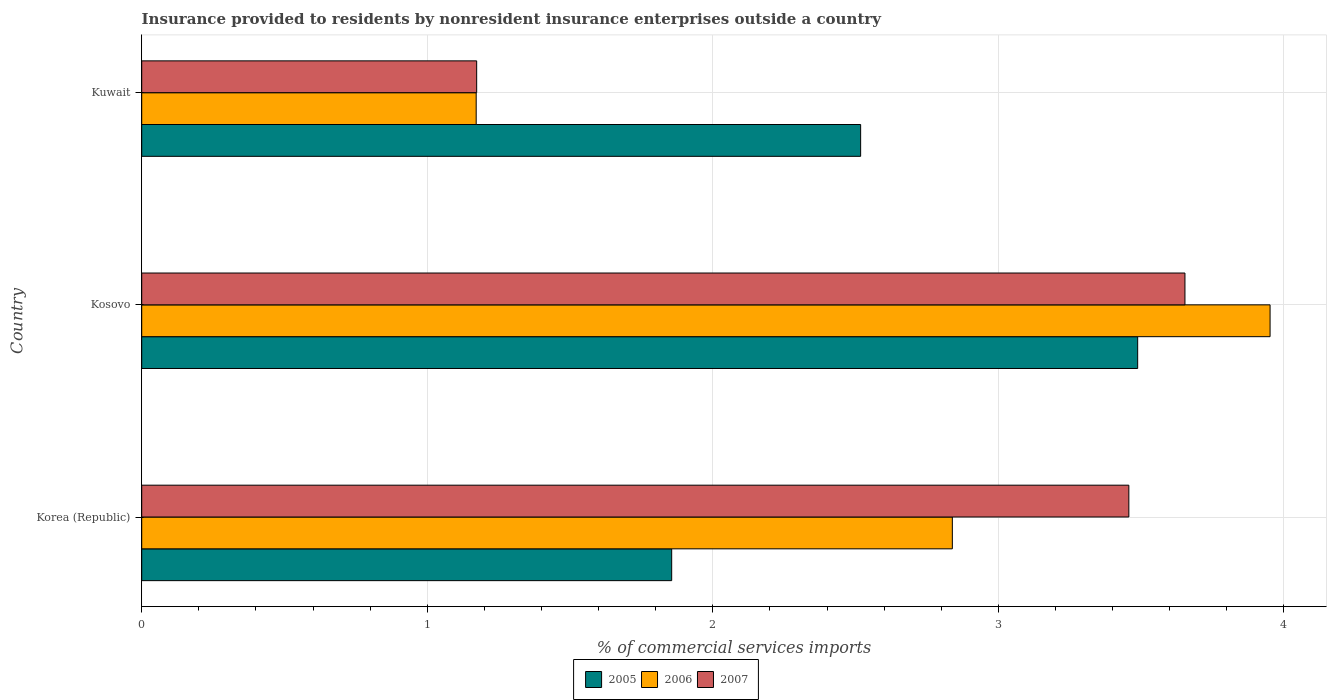How many different coloured bars are there?
Offer a very short reply. 3. How many groups of bars are there?
Your answer should be very brief. 3. Are the number of bars per tick equal to the number of legend labels?
Keep it short and to the point. Yes. Are the number of bars on each tick of the Y-axis equal?
Provide a succinct answer. Yes. How many bars are there on the 1st tick from the top?
Your answer should be compact. 3. How many bars are there on the 2nd tick from the bottom?
Your answer should be very brief. 3. What is the label of the 1st group of bars from the top?
Ensure brevity in your answer.  Kuwait. In how many cases, is the number of bars for a given country not equal to the number of legend labels?
Your response must be concise. 0. What is the Insurance provided to residents in 2006 in Korea (Republic)?
Your response must be concise. 2.84. Across all countries, what is the maximum Insurance provided to residents in 2006?
Your answer should be very brief. 3.95. Across all countries, what is the minimum Insurance provided to residents in 2006?
Your answer should be very brief. 1.17. In which country was the Insurance provided to residents in 2007 maximum?
Provide a succinct answer. Kosovo. In which country was the Insurance provided to residents in 2006 minimum?
Offer a terse response. Kuwait. What is the total Insurance provided to residents in 2007 in the graph?
Offer a terse response. 8.28. What is the difference between the Insurance provided to residents in 2006 in Kosovo and that in Kuwait?
Ensure brevity in your answer.  2.78. What is the difference between the Insurance provided to residents in 2005 in Kuwait and the Insurance provided to residents in 2007 in Kosovo?
Make the answer very short. -1.14. What is the average Insurance provided to residents in 2007 per country?
Your answer should be very brief. 2.76. What is the difference between the Insurance provided to residents in 2006 and Insurance provided to residents in 2005 in Korea (Republic)?
Offer a terse response. 0.98. What is the ratio of the Insurance provided to residents in 2006 in Korea (Republic) to that in Kuwait?
Provide a short and direct response. 2.42. Is the Insurance provided to residents in 2005 in Korea (Republic) less than that in Kosovo?
Provide a short and direct response. Yes. Is the difference between the Insurance provided to residents in 2006 in Kosovo and Kuwait greater than the difference between the Insurance provided to residents in 2005 in Kosovo and Kuwait?
Offer a terse response. Yes. What is the difference between the highest and the second highest Insurance provided to residents in 2005?
Give a very brief answer. 0.97. What is the difference between the highest and the lowest Insurance provided to residents in 2005?
Your response must be concise. 1.63. What does the 2nd bar from the top in Korea (Republic) represents?
Give a very brief answer. 2006. What does the 2nd bar from the bottom in Kuwait represents?
Provide a succinct answer. 2006. Are all the bars in the graph horizontal?
Provide a succinct answer. Yes. How many countries are there in the graph?
Your response must be concise. 3. Are the values on the major ticks of X-axis written in scientific E-notation?
Your answer should be very brief. No. Does the graph contain any zero values?
Your answer should be very brief. No. What is the title of the graph?
Keep it short and to the point. Insurance provided to residents by nonresident insurance enterprises outside a country. Does "1966" appear as one of the legend labels in the graph?
Keep it short and to the point. No. What is the label or title of the X-axis?
Ensure brevity in your answer.  % of commercial services imports. What is the % of commercial services imports of 2005 in Korea (Republic)?
Offer a terse response. 1.86. What is the % of commercial services imports of 2006 in Korea (Republic)?
Provide a short and direct response. 2.84. What is the % of commercial services imports in 2007 in Korea (Republic)?
Offer a very short reply. 3.46. What is the % of commercial services imports of 2005 in Kosovo?
Keep it short and to the point. 3.49. What is the % of commercial services imports in 2006 in Kosovo?
Offer a terse response. 3.95. What is the % of commercial services imports in 2007 in Kosovo?
Offer a terse response. 3.65. What is the % of commercial services imports of 2005 in Kuwait?
Make the answer very short. 2.52. What is the % of commercial services imports in 2006 in Kuwait?
Offer a very short reply. 1.17. What is the % of commercial services imports in 2007 in Kuwait?
Provide a succinct answer. 1.17. Across all countries, what is the maximum % of commercial services imports of 2005?
Your answer should be compact. 3.49. Across all countries, what is the maximum % of commercial services imports in 2006?
Give a very brief answer. 3.95. Across all countries, what is the maximum % of commercial services imports of 2007?
Offer a very short reply. 3.65. Across all countries, what is the minimum % of commercial services imports of 2005?
Offer a very short reply. 1.86. Across all countries, what is the minimum % of commercial services imports in 2006?
Make the answer very short. 1.17. Across all countries, what is the minimum % of commercial services imports in 2007?
Provide a succinct answer. 1.17. What is the total % of commercial services imports in 2005 in the graph?
Your answer should be very brief. 7.86. What is the total % of commercial services imports in 2006 in the graph?
Your response must be concise. 7.96. What is the total % of commercial services imports of 2007 in the graph?
Keep it short and to the point. 8.28. What is the difference between the % of commercial services imports of 2005 in Korea (Republic) and that in Kosovo?
Provide a short and direct response. -1.63. What is the difference between the % of commercial services imports of 2006 in Korea (Republic) and that in Kosovo?
Keep it short and to the point. -1.11. What is the difference between the % of commercial services imports in 2007 in Korea (Republic) and that in Kosovo?
Offer a terse response. -0.2. What is the difference between the % of commercial services imports of 2005 in Korea (Republic) and that in Kuwait?
Provide a short and direct response. -0.66. What is the difference between the % of commercial services imports in 2006 in Korea (Republic) and that in Kuwait?
Your response must be concise. 1.67. What is the difference between the % of commercial services imports in 2007 in Korea (Republic) and that in Kuwait?
Provide a short and direct response. 2.28. What is the difference between the % of commercial services imports in 2005 in Kosovo and that in Kuwait?
Your response must be concise. 0.97. What is the difference between the % of commercial services imports of 2006 in Kosovo and that in Kuwait?
Give a very brief answer. 2.78. What is the difference between the % of commercial services imports in 2007 in Kosovo and that in Kuwait?
Offer a terse response. 2.48. What is the difference between the % of commercial services imports in 2005 in Korea (Republic) and the % of commercial services imports in 2006 in Kosovo?
Provide a succinct answer. -2.1. What is the difference between the % of commercial services imports of 2005 in Korea (Republic) and the % of commercial services imports of 2007 in Kosovo?
Ensure brevity in your answer.  -1.8. What is the difference between the % of commercial services imports in 2006 in Korea (Republic) and the % of commercial services imports in 2007 in Kosovo?
Make the answer very short. -0.81. What is the difference between the % of commercial services imports in 2005 in Korea (Republic) and the % of commercial services imports in 2006 in Kuwait?
Provide a succinct answer. 0.68. What is the difference between the % of commercial services imports in 2005 in Korea (Republic) and the % of commercial services imports in 2007 in Kuwait?
Ensure brevity in your answer.  0.68. What is the difference between the % of commercial services imports in 2006 in Korea (Republic) and the % of commercial services imports in 2007 in Kuwait?
Give a very brief answer. 1.67. What is the difference between the % of commercial services imports of 2005 in Kosovo and the % of commercial services imports of 2006 in Kuwait?
Offer a terse response. 2.32. What is the difference between the % of commercial services imports of 2005 in Kosovo and the % of commercial services imports of 2007 in Kuwait?
Offer a very short reply. 2.31. What is the difference between the % of commercial services imports of 2006 in Kosovo and the % of commercial services imports of 2007 in Kuwait?
Make the answer very short. 2.78. What is the average % of commercial services imports of 2005 per country?
Keep it short and to the point. 2.62. What is the average % of commercial services imports of 2006 per country?
Keep it short and to the point. 2.65. What is the average % of commercial services imports in 2007 per country?
Your answer should be very brief. 2.76. What is the difference between the % of commercial services imports of 2005 and % of commercial services imports of 2006 in Korea (Republic)?
Your response must be concise. -0.98. What is the difference between the % of commercial services imports of 2005 and % of commercial services imports of 2007 in Korea (Republic)?
Make the answer very short. -1.6. What is the difference between the % of commercial services imports of 2006 and % of commercial services imports of 2007 in Korea (Republic)?
Provide a succinct answer. -0.62. What is the difference between the % of commercial services imports of 2005 and % of commercial services imports of 2006 in Kosovo?
Give a very brief answer. -0.46. What is the difference between the % of commercial services imports in 2005 and % of commercial services imports in 2007 in Kosovo?
Provide a succinct answer. -0.17. What is the difference between the % of commercial services imports in 2006 and % of commercial services imports in 2007 in Kosovo?
Offer a terse response. 0.3. What is the difference between the % of commercial services imports of 2005 and % of commercial services imports of 2006 in Kuwait?
Offer a terse response. 1.35. What is the difference between the % of commercial services imports of 2005 and % of commercial services imports of 2007 in Kuwait?
Ensure brevity in your answer.  1.34. What is the difference between the % of commercial services imports in 2006 and % of commercial services imports in 2007 in Kuwait?
Give a very brief answer. -0. What is the ratio of the % of commercial services imports of 2005 in Korea (Republic) to that in Kosovo?
Offer a very short reply. 0.53. What is the ratio of the % of commercial services imports of 2006 in Korea (Republic) to that in Kosovo?
Offer a very short reply. 0.72. What is the ratio of the % of commercial services imports in 2007 in Korea (Republic) to that in Kosovo?
Keep it short and to the point. 0.95. What is the ratio of the % of commercial services imports in 2005 in Korea (Republic) to that in Kuwait?
Offer a terse response. 0.74. What is the ratio of the % of commercial services imports in 2006 in Korea (Republic) to that in Kuwait?
Give a very brief answer. 2.42. What is the ratio of the % of commercial services imports in 2007 in Korea (Republic) to that in Kuwait?
Provide a succinct answer. 2.95. What is the ratio of the % of commercial services imports in 2005 in Kosovo to that in Kuwait?
Your response must be concise. 1.39. What is the ratio of the % of commercial services imports of 2006 in Kosovo to that in Kuwait?
Offer a terse response. 3.37. What is the ratio of the % of commercial services imports of 2007 in Kosovo to that in Kuwait?
Offer a terse response. 3.11. What is the difference between the highest and the second highest % of commercial services imports of 2005?
Provide a succinct answer. 0.97. What is the difference between the highest and the second highest % of commercial services imports in 2006?
Your answer should be compact. 1.11. What is the difference between the highest and the second highest % of commercial services imports of 2007?
Keep it short and to the point. 0.2. What is the difference between the highest and the lowest % of commercial services imports of 2005?
Ensure brevity in your answer.  1.63. What is the difference between the highest and the lowest % of commercial services imports of 2006?
Give a very brief answer. 2.78. What is the difference between the highest and the lowest % of commercial services imports of 2007?
Give a very brief answer. 2.48. 